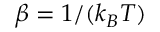Convert formula to latex. <formula><loc_0><loc_0><loc_500><loc_500>\beta = 1 / ( k _ { B } T )</formula> 